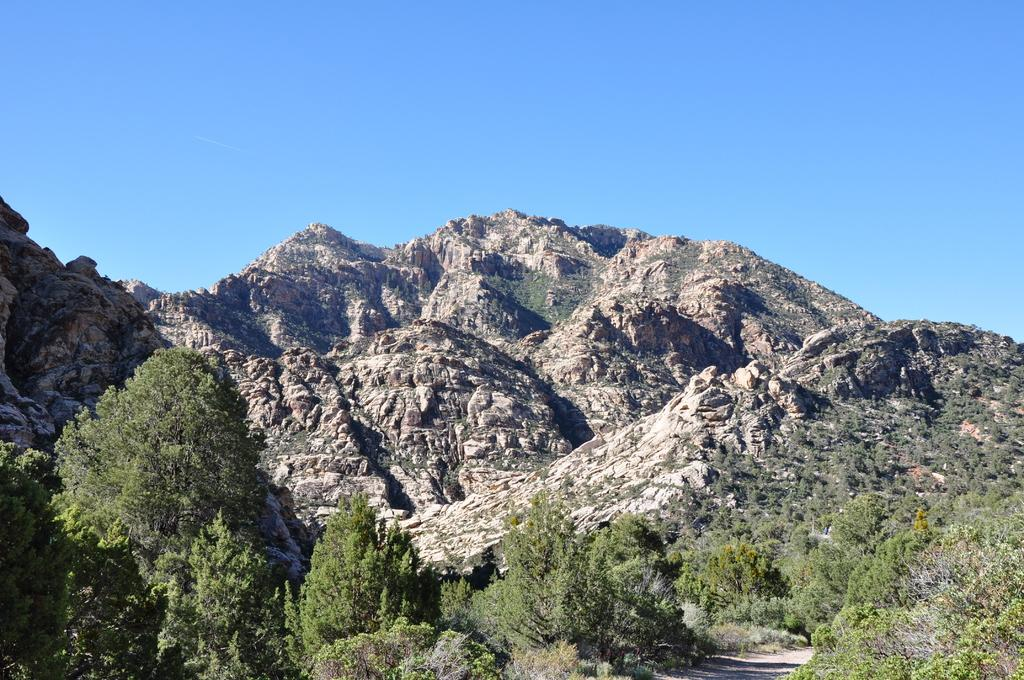What type of natural landform can be seen in the image? There are mountains in the image. What type of vegetation is present in the image? There are trees in the image. What part of the natural environment is visible in the image? The sky is visible in the image. What advice does the uncle give in the image? There is no uncle present in the image, so it is not possible to answer that question. 